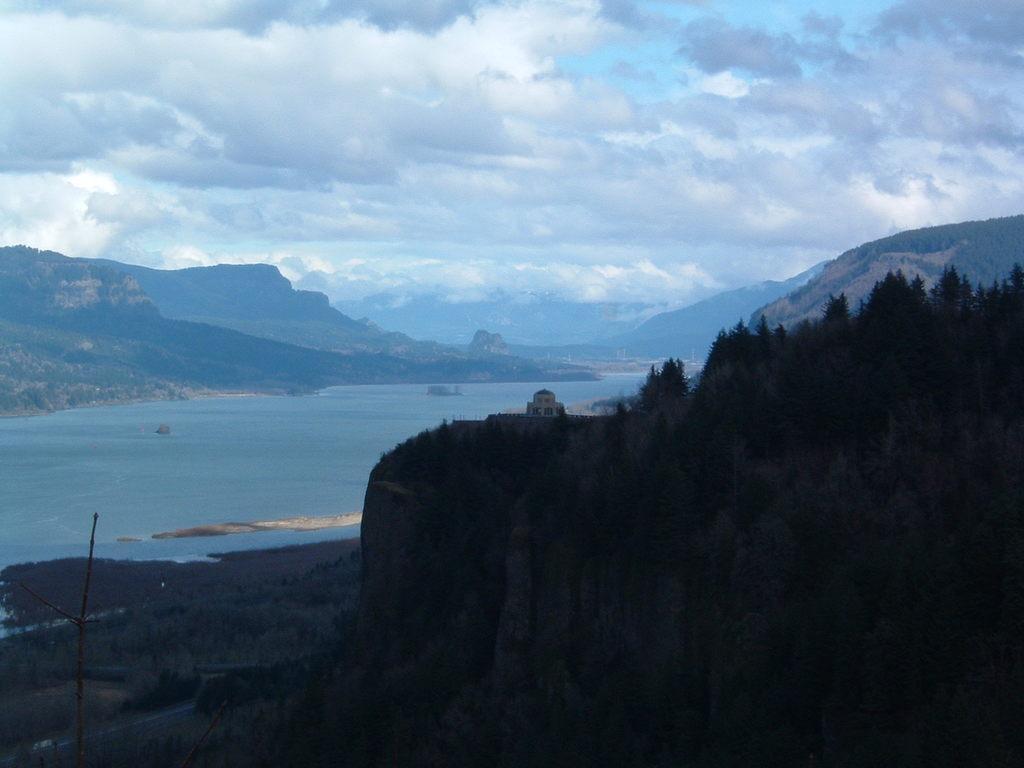In one or two sentences, can you explain what this image depicts? In this picture we can see few trees and water, in the background we can see hills and clouds. 